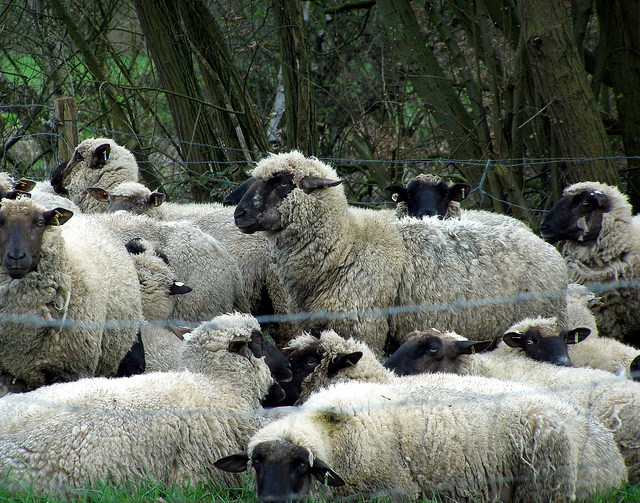If you were to imagine a story or event leading up to this scene, what might it be? Imagining a narrative for this scene, it seems like the sheep could be part of a rural farm. They might have spent the early hours roaming and grazing across a wide field. As the day progressed, perhaps a shepherd called them back to a central area near the fence for feeding or to ensure their safety. The dense vegetation and tranquility of the background imply a secluded, peaceful environment that offers the sheep a serene place to gather and rest. 